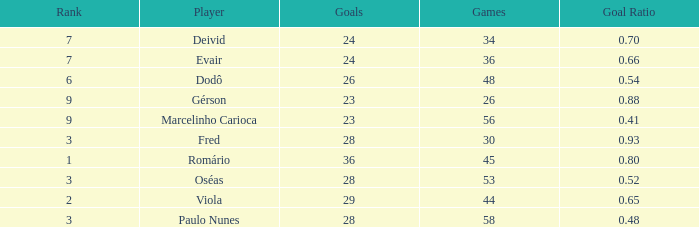How many goals have a goal ration less than 0.8 with 56 games? 1.0. 